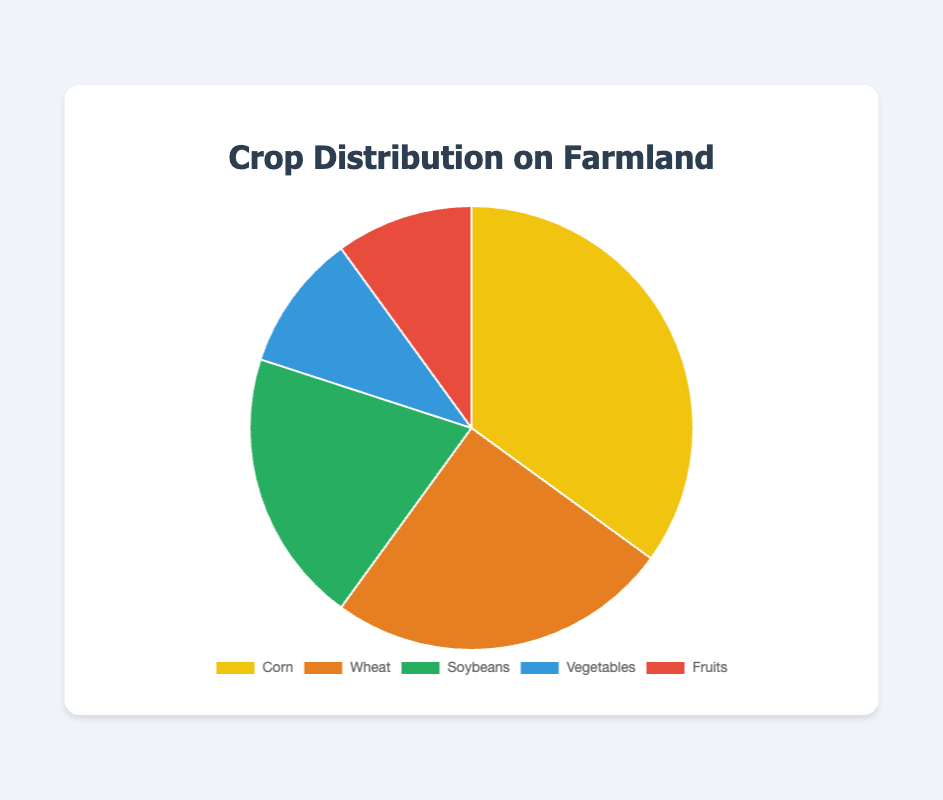Which crop type has the highest percentage? The crop type with the highest percentage can be identified by looking at the data or the largest slice of the pie chart, which is labeled as Corn.
Answer: Corn Which two crop types have an equal percentage? By examining the data, you can see that the percentages are 35% for Corn, 25% for Wheat, 20% for Soybeans, and two categories, Vegetables and Fruits, each have 10%.
Answer: Vegetables and Fruits What is the combined percentage of Soybeans and Vegetables? Adding the percentage of Soybeans (20%) and Vegetables (10%) gives a total combined percentage. 20% + 10% = 30%
Answer: 30% Which crop type contributes exactly a quarter of the farmland? From the data, Wheat contributes 25% which is exactly one-quarter of the farmland.
Answer: Wheat How much greater is the percentage of Corn compared to Fruits? Subtracting the percentage of Fruits (10%) from the percentage of Corn (35%) gives the difference. 35% - 10% = 25%
Answer: 25% What percentage of crops other than Corn and Wheat are cultivated? Adding the percentages of all crops except Corn (35%) and Wheat (25%) involves adding Soybeans (20%), Vegetables (10%), and Fruits (10%). 20% + 10% + 10% = 40%
Answer: 40% What color is the segment representing Wheat? The segment representing Wheat can be identified in the legend and pie chart as the second item, which is colored orange.
Answer: Orange By how much does the cumulative percentage of Vegetables and Fruits fall short of the percentage for Corn? Adding the percentages for Vegetables (10%) and Fruits (10%) gives 20%. The shortfall compared to Corn (35%) is calculated as 35% - 20% = 15%.
Answer: 15% Which type of crop has the smallest share of the farmland? By looking at the data, the smallest shares are Vegetables and Fruits, each contributing 10%.
Answer: Vegetables and Fruits What is the average percentage of all the crops on the farmland? Adding all the percentages 35% (Corn) + 25% (Wheat) + 20% (Soybeans) + 10% (Vegetables) + 10% (Fruits) = 100%. The average is then 100% / 5 crop types = 20%.
Answer: 20% 